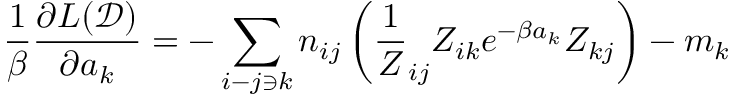<formula> <loc_0><loc_0><loc_500><loc_500>\frac { 1 } { \beta } \frac { \partial L ( \mathcal { D } ) } { \partial a _ { k } } = - \sum _ { i - j \ni k } n _ { i j } \left ( \frac { 1 } { Z } _ { i j } Z _ { i k } e ^ { - \beta a _ { k } } Z _ { k j } \right ) - m _ { k }</formula> 